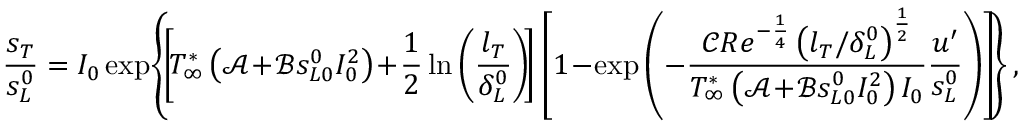Convert formula to latex. <formula><loc_0><loc_0><loc_500><loc_500>\frac { s _ { T } } { s _ { L } ^ { 0 } } = I _ { 0 } \exp \, \left \{ \, \left [ \, T _ { \infty } ^ { * } \left ( \mathcal { A } \, + \, \mathcal { B } s _ { L 0 } ^ { 0 } I _ { 0 } ^ { 2 } \right ) \, + \, \frac { 1 } { 2 } \ln \left ( \frac { l _ { T } } { \delta _ { L } ^ { 0 } } \right ) \, \right ] \left [ 1 \, - \, \exp \left ( - \frac { \mathcal { C } R e ^ { - \frac { 1 } { 4 } } \left ( l _ { T } / \delta _ { L } ^ { 0 } \right ) ^ { \frac { 1 } { 2 } } } { T _ { \infty } ^ { * } \left ( \mathcal { A } \, + \, \mathcal { B } s _ { L 0 } ^ { 0 } I _ { 0 } ^ { 2 } \right ) I _ { 0 } } \frac { u ^ { \prime } } { s _ { L } ^ { 0 } } \right ) \right ] \, \right \} ,</formula> 